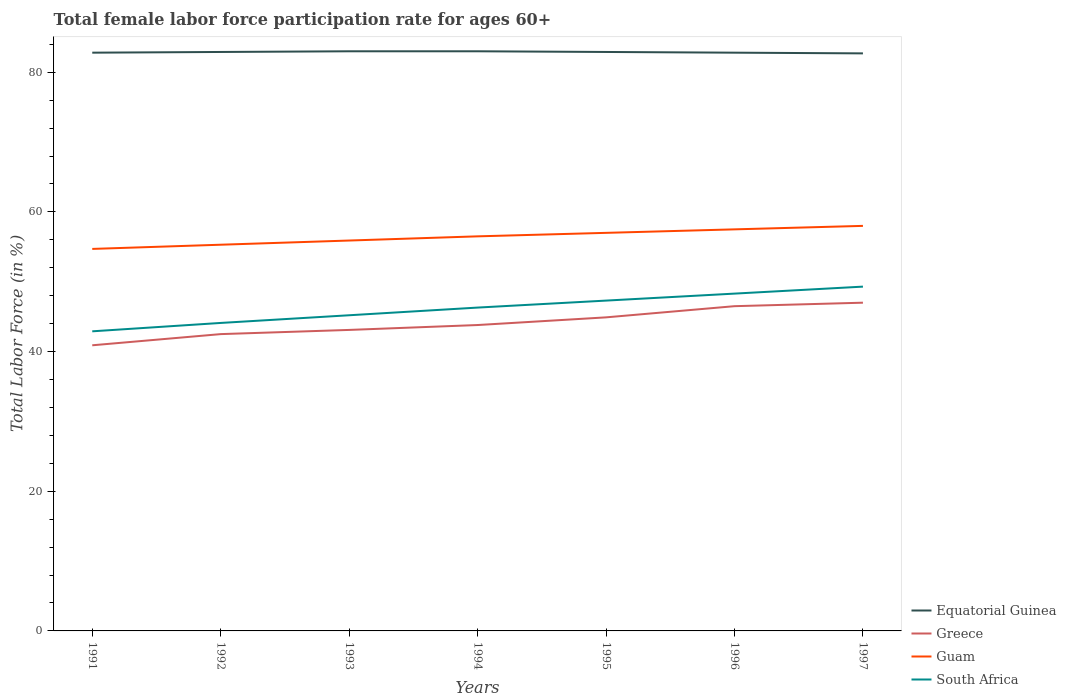How many different coloured lines are there?
Your answer should be very brief. 4. Does the line corresponding to Greece intersect with the line corresponding to South Africa?
Offer a very short reply. No. Is the number of lines equal to the number of legend labels?
Your answer should be very brief. Yes. Across all years, what is the maximum female labor force participation rate in Greece?
Your answer should be compact. 40.9. In which year was the female labor force participation rate in Greece maximum?
Offer a very short reply. 1991. What is the total female labor force participation rate in Greece in the graph?
Offer a terse response. -1.1. What is the difference between the highest and the second highest female labor force participation rate in Greece?
Your response must be concise. 6.1. What is the difference between the highest and the lowest female labor force participation rate in Guam?
Offer a very short reply. 4. How many lines are there?
Ensure brevity in your answer.  4. What is the difference between two consecutive major ticks on the Y-axis?
Provide a succinct answer. 20. Where does the legend appear in the graph?
Keep it short and to the point. Bottom right. What is the title of the graph?
Your answer should be compact. Total female labor force participation rate for ages 60+. What is the label or title of the Y-axis?
Your response must be concise. Total Labor Force (in %). What is the Total Labor Force (in %) in Equatorial Guinea in 1991?
Your response must be concise. 82.8. What is the Total Labor Force (in %) in Greece in 1991?
Your answer should be very brief. 40.9. What is the Total Labor Force (in %) in Guam in 1991?
Ensure brevity in your answer.  54.7. What is the Total Labor Force (in %) of South Africa in 1991?
Provide a short and direct response. 42.9. What is the Total Labor Force (in %) of Equatorial Guinea in 1992?
Keep it short and to the point. 82.9. What is the Total Labor Force (in %) of Greece in 1992?
Provide a succinct answer. 42.5. What is the Total Labor Force (in %) of Guam in 1992?
Offer a terse response. 55.3. What is the Total Labor Force (in %) of South Africa in 1992?
Offer a very short reply. 44.1. What is the Total Labor Force (in %) of Equatorial Guinea in 1993?
Your response must be concise. 83. What is the Total Labor Force (in %) of Greece in 1993?
Your answer should be compact. 43.1. What is the Total Labor Force (in %) of Guam in 1993?
Offer a very short reply. 55.9. What is the Total Labor Force (in %) of South Africa in 1993?
Make the answer very short. 45.2. What is the Total Labor Force (in %) in Greece in 1994?
Give a very brief answer. 43.8. What is the Total Labor Force (in %) of Guam in 1994?
Your response must be concise. 56.5. What is the Total Labor Force (in %) of South Africa in 1994?
Your answer should be compact. 46.3. What is the Total Labor Force (in %) of Equatorial Guinea in 1995?
Keep it short and to the point. 82.9. What is the Total Labor Force (in %) in Greece in 1995?
Keep it short and to the point. 44.9. What is the Total Labor Force (in %) in Guam in 1995?
Ensure brevity in your answer.  57. What is the Total Labor Force (in %) in South Africa in 1995?
Your answer should be very brief. 47.3. What is the Total Labor Force (in %) of Equatorial Guinea in 1996?
Offer a terse response. 82.8. What is the Total Labor Force (in %) of Greece in 1996?
Ensure brevity in your answer.  46.5. What is the Total Labor Force (in %) of Guam in 1996?
Offer a terse response. 57.5. What is the Total Labor Force (in %) in South Africa in 1996?
Ensure brevity in your answer.  48.3. What is the Total Labor Force (in %) in Equatorial Guinea in 1997?
Provide a succinct answer. 82.7. What is the Total Labor Force (in %) in Guam in 1997?
Ensure brevity in your answer.  58. What is the Total Labor Force (in %) in South Africa in 1997?
Offer a terse response. 49.3. Across all years, what is the maximum Total Labor Force (in %) in Equatorial Guinea?
Your answer should be very brief. 83. Across all years, what is the maximum Total Labor Force (in %) of Greece?
Give a very brief answer. 47. Across all years, what is the maximum Total Labor Force (in %) of South Africa?
Provide a short and direct response. 49.3. Across all years, what is the minimum Total Labor Force (in %) in Equatorial Guinea?
Give a very brief answer. 82.7. Across all years, what is the minimum Total Labor Force (in %) in Greece?
Your answer should be compact. 40.9. Across all years, what is the minimum Total Labor Force (in %) of Guam?
Your response must be concise. 54.7. Across all years, what is the minimum Total Labor Force (in %) of South Africa?
Provide a short and direct response. 42.9. What is the total Total Labor Force (in %) in Equatorial Guinea in the graph?
Provide a succinct answer. 580.1. What is the total Total Labor Force (in %) in Greece in the graph?
Provide a succinct answer. 308.7. What is the total Total Labor Force (in %) of Guam in the graph?
Your response must be concise. 394.9. What is the total Total Labor Force (in %) of South Africa in the graph?
Provide a short and direct response. 323.4. What is the difference between the Total Labor Force (in %) of Equatorial Guinea in 1991 and that in 1992?
Make the answer very short. -0.1. What is the difference between the Total Labor Force (in %) of South Africa in 1991 and that in 1992?
Offer a very short reply. -1.2. What is the difference between the Total Labor Force (in %) in Equatorial Guinea in 1991 and that in 1993?
Offer a very short reply. -0.2. What is the difference between the Total Labor Force (in %) of Equatorial Guinea in 1991 and that in 1994?
Provide a succinct answer. -0.2. What is the difference between the Total Labor Force (in %) of Guam in 1991 and that in 1994?
Your response must be concise. -1.8. What is the difference between the Total Labor Force (in %) of Equatorial Guinea in 1991 and that in 1995?
Offer a terse response. -0.1. What is the difference between the Total Labor Force (in %) of Equatorial Guinea in 1991 and that in 1996?
Your answer should be compact. 0. What is the difference between the Total Labor Force (in %) in Greece in 1991 and that in 1996?
Ensure brevity in your answer.  -5.6. What is the difference between the Total Labor Force (in %) in Guam in 1991 and that in 1996?
Make the answer very short. -2.8. What is the difference between the Total Labor Force (in %) of Guam in 1991 and that in 1997?
Ensure brevity in your answer.  -3.3. What is the difference between the Total Labor Force (in %) of South Africa in 1991 and that in 1997?
Offer a terse response. -6.4. What is the difference between the Total Labor Force (in %) in Greece in 1992 and that in 1993?
Your answer should be very brief. -0.6. What is the difference between the Total Labor Force (in %) of Guam in 1992 and that in 1993?
Your answer should be very brief. -0.6. What is the difference between the Total Labor Force (in %) in South Africa in 1992 and that in 1993?
Keep it short and to the point. -1.1. What is the difference between the Total Labor Force (in %) of Guam in 1992 and that in 1994?
Your answer should be compact. -1.2. What is the difference between the Total Labor Force (in %) of Guam in 1992 and that in 1995?
Offer a very short reply. -1.7. What is the difference between the Total Labor Force (in %) in Equatorial Guinea in 1992 and that in 1996?
Make the answer very short. 0.1. What is the difference between the Total Labor Force (in %) in South Africa in 1992 and that in 1996?
Give a very brief answer. -4.2. What is the difference between the Total Labor Force (in %) in Equatorial Guinea in 1992 and that in 1997?
Your answer should be compact. 0.2. What is the difference between the Total Labor Force (in %) of Greece in 1992 and that in 1997?
Provide a short and direct response. -4.5. What is the difference between the Total Labor Force (in %) in South Africa in 1992 and that in 1997?
Your response must be concise. -5.2. What is the difference between the Total Labor Force (in %) in Guam in 1993 and that in 1994?
Provide a short and direct response. -0.6. What is the difference between the Total Labor Force (in %) of South Africa in 1993 and that in 1994?
Offer a very short reply. -1.1. What is the difference between the Total Labor Force (in %) in Guam in 1993 and that in 1995?
Your answer should be very brief. -1.1. What is the difference between the Total Labor Force (in %) in South Africa in 1993 and that in 1995?
Provide a succinct answer. -2.1. What is the difference between the Total Labor Force (in %) of South Africa in 1993 and that in 1996?
Make the answer very short. -3.1. What is the difference between the Total Labor Force (in %) of Guam in 1993 and that in 1997?
Give a very brief answer. -2.1. What is the difference between the Total Labor Force (in %) in Greece in 1994 and that in 1995?
Make the answer very short. -1.1. What is the difference between the Total Labor Force (in %) in Guam in 1994 and that in 1995?
Your answer should be very brief. -0.5. What is the difference between the Total Labor Force (in %) of South Africa in 1994 and that in 1995?
Keep it short and to the point. -1. What is the difference between the Total Labor Force (in %) of Greece in 1994 and that in 1996?
Make the answer very short. -2.7. What is the difference between the Total Labor Force (in %) of South Africa in 1994 and that in 1996?
Make the answer very short. -2. What is the difference between the Total Labor Force (in %) in South Africa in 1994 and that in 1997?
Your answer should be compact. -3. What is the difference between the Total Labor Force (in %) in South Africa in 1995 and that in 1996?
Give a very brief answer. -1. What is the difference between the Total Labor Force (in %) in Equatorial Guinea in 1995 and that in 1997?
Your answer should be compact. 0.2. What is the difference between the Total Labor Force (in %) in Guam in 1995 and that in 1997?
Your answer should be compact. -1. What is the difference between the Total Labor Force (in %) in South Africa in 1995 and that in 1997?
Give a very brief answer. -2. What is the difference between the Total Labor Force (in %) in Equatorial Guinea in 1996 and that in 1997?
Offer a terse response. 0.1. What is the difference between the Total Labor Force (in %) in Greece in 1996 and that in 1997?
Provide a succinct answer. -0.5. What is the difference between the Total Labor Force (in %) in South Africa in 1996 and that in 1997?
Offer a terse response. -1. What is the difference between the Total Labor Force (in %) in Equatorial Guinea in 1991 and the Total Labor Force (in %) in Greece in 1992?
Offer a terse response. 40.3. What is the difference between the Total Labor Force (in %) of Equatorial Guinea in 1991 and the Total Labor Force (in %) of Guam in 1992?
Your answer should be compact. 27.5. What is the difference between the Total Labor Force (in %) in Equatorial Guinea in 1991 and the Total Labor Force (in %) in South Africa in 1992?
Make the answer very short. 38.7. What is the difference between the Total Labor Force (in %) in Greece in 1991 and the Total Labor Force (in %) in Guam in 1992?
Provide a succinct answer. -14.4. What is the difference between the Total Labor Force (in %) of Greece in 1991 and the Total Labor Force (in %) of South Africa in 1992?
Your response must be concise. -3.2. What is the difference between the Total Labor Force (in %) of Guam in 1991 and the Total Labor Force (in %) of South Africa in 1992?
Your answer should be very brief. 10.6. What is the difference between the Total Labor Force (in %) in Equatorial Guinea in 1991 and the Total Labor Force (in %) in Greece in 1993?
Give a very brief answer. 39.7. What is the difference between the Total Labor Force (in %) of Equatorial Guinea in 1991 and the Total Labor Force (in %) of Guam in 1993?
Your answer should be compact. 26.9. What is the difference between the Total Labor Force (in %) in Equatorial Guinea in 1991 and the Total Labor Force (in %) in South Africa in 1993?
Provide a short and direct response. 37.6. What is the difference between the Total Labor Force (in %) in Equatorial Guinea in 1991 and the Total Labor Force (in %) in Guam in 1994?
Make the answer very short. 26.3. What is the difference between the Total Labor Force (in %) in Equatorial Guinea in 1991 and the Total Labor Force (in %) in South Africa in 1994?
Provide a succinct answer. 36.5. What is the difference between the Total Labor Force (in %) of Greece in 1991 and the Total Labor Force (in %) of Guam in 1994?
Give a very brief answer. -15.6. What is the difference between the Total Labor Force (in %) in Greece in 1991 and the Total Labor Force (in %) in South Africa in 1994?
Give a very brief answer. -5.4. What is the difference between the Total Labor Force (in %) of Equatorial Guinea in 1991 and the Total Labor Force (in %) of Greece in 1995?
Keep it short and to the point. 37.9. What is the difference between the Total Labor Force (in %) in Equatorial Guinea in 1991 and the Total Labor Force (in %) in Guam in 1995?
Offer a terse response. 25.8. What is the difference between the Total Labor Force (in %) of Equatorial Guinea in 1991 and the Total Labor Force (in %) of South Africa in 1995?
Provide a short and direct response. 35.5. What is the difference between the Total Labor Force (in %) in Greece in 1991 and the Total Labor Force (in %) in Guam in 1995?
Your response must be concise. -16.1. What is the difference between the Total Labor Force (in %) of Guam in 1991 and the Total Labor Force (in %) of South Africa in 1995?
Give a very brief answer. 7.4. What is the difference between the Total Labor Force (in %) of Equatorial Guinea in 1991 and the Total Labor Force (in %) of Greece in 1996?
Provide a succinct answer. 36.3. What is the difference between the Total Labor Force (in %) in Equatorial Guinea in 1991 and the Total Labor Force (in %) in Guam in 1996?
Provide a succinct answer. 25.3. What is the difference between the Total Labor Force (in %) in Equatorial Guinea in 1991 and the Total Labor Force (in %) in South Africa in 1996?
Provide a succinct answer. 34.5. What is the difference between the Total Labor Force (in %) of Greece in 1991 and the Total Labor Force (in %) of Guam in 1996?
Offer a very short reply. -16.6. What is the difference between the Total Labor Force (in %) of Guam in 1991 and the Total Labor Force (in %) of South Africa in 1996?
Ensure brevity in your answer.  6.4. What is the difference between the Total Labor Force (in %) in Equatorial Guinea in 1991 and the Total Labor Force (in %) in Greece in 1997?
Keep it short and to the point. 35.8. What is the difference between the Total Labor Force (in %) in Equatorial Guinea in 1991 and the Total Labor Force (in %) in Guam in 1997?
Provide a short and direct response. 24.8. What is the difference between the Total Labor Force (in %) of Equatorial Guinea in 1991 and the Total Labor Force (in %) of South Africa in 1997?
Your response must be concise. 33.5. What is the difference between the Total Labor Force (in %) in Greece in 1991 and the Total Labor Force (in %) in Guam in 1997?
Offer a terse response. -17.1. What is the difference between the Total Labor Force (in %) of Guam in 1991 and the Total Labor Force (in %) of South Africa in 1997?
Provide a succinct answer. 5.4. What is the difference between the Total Labor Force (in %) of Equatorial Guinea in 1992 and the Total Labor Force (in %) of Greece in 1993?
Your response must be concise. 39.8. What is the difference between the Total Labor Force (in %) of Equatorial Guinea in 1992 and the Total Labor Force (in %) of South Africa in 1993?
Make the answer very short. 37.7. What is the difference between the Total Labor Force (in %) in Greece in 1992 and the Total Labor Force (in %) in Guam in 1993?
Keep it short and to the point. -13.4. What is the difference between the Total Labor Force (in %) in Greece in 1992 and the Total Labor Force (in %) in South Africa in 1993?
Keep it short and to the point. -2.7. What is the difference between the Total Labor Force (in %) in Guam in 1992 and the Total Labor Force (in %) in South Africa in 1993?
Provide a short and direct response. 10.1. What is the difference between the Total Labor Force (in %) of Equatorial Guinea in 1992 and the Total Labor Force (in %) of Greece in 1994?
Ensure brevity in your answer.  39.1. What is the difference between the Total Labor Force (in %) of Equatorial Guinea in 1992 and the Total Labor Force (in %) of Guam in 1994?
Your answer should be compact. 26.4. What is the difference between the Total Labor Force (in %) in Equatorial Guinea in 1992 and the Total Labor Force (in %) in South Africa in 1994?
Offer a very short reply. 36.6. What is the difference between the Total Labor Force (in %) in Greece in 1992 and the Total Labor Force (in %) in Guam in 1994?
Ensure brevity in your answer.  -14. What is the difference between the Total Labor Force (in %) of Greece in 1992 and the Total Labor Force (in %) of South Africa in 1994?
Your answer should be very brief. -3.8. What is the difference between the Total Labor Force (in %) of Guam in 1992 and the Total Labor Force (in %) of South Africa in 1994?
Offer a terse response. 9. What is the difference between the Total Labor Force (in %) in Equatorial Guinea in 1992 and the Total Labor Force (in %) in Guam in 1995?
Ensure brevity in your answer.  25.9. What is the difference between the Total Labor Force (in %) of Equatorial Guinea in 1992 and the Total Labor Force (in %) of South Africa in 1995?
Give a very brief answer. 35.6. What is the difference between the Total Labor Force (in %) of Equatorial Guinea in 1992 and the Total Labor Force (in %) of Greece in 1996?
Provide a short and direct response. 36.4. What is the difference between the Total Labor Force (in %) in Equatorial Guinea in 1992 and the Total Labor Force (in %) in Guam in 1996?
Make the answer very short. 25.4. What is the difference between the Total Labor Force (in %) of Equatorial Guinea in 1992 and the Total Labor Force (in %) of South Africa in 1996?
Your response must be concise. 34.6. What is the difference between the Total Labor Force (in %) in Greece in 1992 and the Total Labor Force (in %) in South Africa in 1996?
Give a very brief answer. -5.8. What is the difference between the Total Labor Force (in %) of Equatorial Guinea in 1992 and the Total Labor Force (in %) of Greece in 1997?
Provide a succinct answer. 35.9. What is the difference between the Total Labor Force (in %) of Equatorial Guinea in 1992 and the Total Labor Force (in %) of Guam in 1997?
Provide a short and direct response. 24.9. What is the difference between the Total Labor Force (in %) in Equatorial Guinea in 1992 and the Total Labor Force (in %) in South Africa in 1997?
Ensure brevity in your answer.  33.6. What is the difference between the Total Labor Force (in %) in Greece in 1992 and the Total Labor Force (in %) in Guam in 1997?
Offer a very short reply. -15.5. What is the difference between the Total Labor Force (in %) in Equatorial Guinea in 1993 and the Total Labor Force (in %) in Greece in 1994?
Your answer should be compact. 39.2. What is the difference between the Total Labor Force (in %) of Equatorial Guinea in 1993 and the Total Labor Force (in %) of South Africa in 1994?
Give a very brief answer. 36.7. What is the difference between the Total Labor Force (in %) of Greece in 1993 and the Total Labor Force (in %) of South Africa in 1994?
Your response must be concise. -3.2. What is the difference between the Total Labor Force (in %) in Guam in 1993 and the Total Labor Force (in %) in South Africa in 1994?
Your answer should be compact. 9.6. What is the difference between the Total Labor Force (in %) of Equatorial Guinea in 1993 and the Total Labor Force (in %) of Greece in 1995?
Provide a short and direct response. 38.1. What is the difference between the Total Labor Force (in %) in Equatorial Guinea in 1993 and the Total Labor Force (in %) in Guam in 1995?
Offer a very short reply. 26. What is the difference between the Total Labor Force (in %) of Equatorial Guinea in 1993 and the Total Labor Force (in %) of South Africa in 1995?
Provide a succinct answer. 35.7. What is the difference between the Total Labor Force (in %) in Equatorial Guinea in 1993 and the Total Labor Force (in %) in Greece in 1996?
Your response must be concise. 36.5. What is the difference between the Total Labor Force (in %) in Equatorial Guinea in 1993 and the Total Labor Force (in %) in Guam in 1996?
Offer a very short reply. 25.5. What is the difference between the Total Labor Force (in %) in Equatorial Guinea in 1993 and the Total Labor Force (in %) in South Africa in 1996?
Keep it short and to the point. 34.7. What is the difference between the Total Labor Force (in %) in Greece in 1993 and the Total Labor Force (in %) in Guam in 1996?
Your answer should be compact. -14.4. What is the difference between the Total Labor Force (in %) of Greece in 1993 and the Total Labor Force (in %) of South Africa in 1996?
Your response must be concise. -5.2. What is the difference between the Total Labor Force (in %) of Equatorial Guinea in 1993 and the Total Labor Force (in %) of South Africa in 1997?
Offer a very short reply. 33.7. What is the difference between the Total Labor Force (in %) in Greece in 1993 and the Total Labor Force (in %) in Guam in 1997?
Keep it short and to the point. -14.9. What is the difference between the Total Labor Force (in %) in Equatorial Guinea in 1994 and the Total Labor Force (in %) in Greece in 1995?
Give a very brief answer. 38.1. What is the difference between the Total Labor Force (in %) of Equatorial Guinea in 1994 and the Total Labor Force (in %) of South Africa in 1995?
Offer a terse response. 35.7. What is the difference between the Total Labor Force (in %) of Greece in 1994 and the Total Labor Force (in %) of Guam in 1995?
Your answer should be very brief. -13.2. What is the difference between the Total Labor Force (in %) of Guam in 1994 and the Total Labor Force (in %) of South Africa in 1995?
Offer a very short reply. 9.2. What is the difference between the Total Labor Force (in %) in Equatorial Guinea in 1994 and the Total Labor Force (in %) in Greece in 1996?
Ensure brevity in your answer.  36.5. What is the difference between the Total Labor Force (in %) in Equatorial Guinea in 1994 and the Total Labor Force (in %) in South Africa in 1996?
Provide a short and direct response. 34.7. What is the difference between the Total Labor Force (in %) of Greece in 1994 and the Total Labor Force (in %) of Guam in 1996?
Provide a short and direct response. -13.7. What is the difference between the Total Labor Force (in %) of Greece in 1994 and the Total Labor Force (in %) of South Africa in 1996?
Provide a succinct answer. -4.5. What is the difference between the Total Labor Force (in %) in Equatorial Guinea in 1994 and the Total Labor Force (in %) in South Africa in 1997?
Keep it short and to the point. 33.7. What is the difference between the Total Labor Force (in %) of Greece in 1994 and the Total Labor Force (in %) of Guam in 1997?
Your response must be concise. -14.2. What is the difference between the Total Labor Force (in %) in Guam in 1994 and the Total Labor Force (in %) in South Africa in 1997?
Your response must be concise. 7.2. What is the difference between the Total Labor Force (in %) in Equatorial Guinea in 1995 and the Total Labor Force (in %) in Greece in 1996?
Ensure brevity in your answer.  36.4. What is the difference between the Total Labor Force (in %) in Equatorial Guinea in 1995 and the Total Labor Force (in %) in Guam in 1996?
Offer a very short reply. 25.4. What is the difference between the Total Labor Force (in %) in Equatorial Guinea in 1995 and the Total Labor Force (in %) in South Africa in 1996?
Give a very brief answer. 34.6. What is the difference between the Total Labor Force (in %) of Greece in 1995 and the Total Labor Force (in %) of Guam in 1996?
Offer a terse response. -12.6. What is the difference between the Total Labor Force (in %) in Greece in 1995 and the Total Labor Force (in %) in South Africa in 1996?
Your answer should be very brief. -3.4. What is the difference between the Total Labor Force (in %) of Equatorial Guinea in 1995 and the Total Labor Force (in %) of Greece in 1997?
Provide a short and direct response. 35.9. What is the difference between the Total Labor Force (in %) in Equatorial Guinea in 1995 and the Total Labor Force (in %) in Guam in 1997?
Give a very brief answer. 24.9. What is the difference between the Total Labor Force (in %) in Equatorial Guinea in 1995 and the Total Labor Force (in %) in South Africa in 1997?
Offer a very short reply. 33.6. What is the difference between the Total Labor Force (in %) of Greece in 1995 and the Total Labor Force (in %) of Guam in 1997?
Ensure brevity in your answer.  -13.1. What is the difference between the Total Labor Force (in %) of Greece in 1995 and the Total Labor Force (in %) of South Africa in 1997?
Offer a very short reply. -4.4. What is the difference between the Total Labor Force (in %) of Equatorial Guinea in 1996 and the Total Labor Force (in %) of Greece in 1997?
Your answer should be compact. 35.8. What is the difference between the Total Labor Force (in %) in Equatorial Guinea in 1996 and the Total Labor Force (in %) in Guam in 1997?
Your answer should be compact. 24.8. What is the difference between the Total Labor Force (in %) in Equatorial Guinea in 1996 and the Total Labor Force (in %) in South Africa in 1997?
Ensure brevity in your answer.  33.5. What is the difference between the Total Labor Force (in %) of Guam in 1996 and the Total Labor Force (in %) of South Africa in 1997?
Give a very brief answer. 8.2. What is the average Total Labor Force (in %) of Equatorial Guinea per year?
Your answer should be very brief. 82.87. What is the average Total Labor Force (in %) of Greece per year?
Your response must be concise. 44.1. What is the average Total Labor Force (in %) of Guam per year?
Offer a terse response. 56.41. What is the average Total Labor Force (in %) of South Africa per year?
Offer a terse response. 46.2. In the year 1991, what is the difference between the Total Labor Force (in %) in Equatorial Guinea and Total Labor Force (in %) in Greece?
Your answer should be very brief. 41.9. In the year 1991, what is the difference between the Total Labor Force (in %) of Equatorial Guinea and Total Labor Force (in %) of Guam?
Your answer should be compact. 28.1. In the year 1991, what is the difference between the Total Labor Force (in %) of Equatorial Guinea and Total Labor Force (in %) of South Africa?
Offer a very short reply. 39.9. In the year 1992, what is the difference between the Total Labor Force (in %) of Equatorial Guinea and Total Labor Force (in %) of Greece?
Provide a succinct answer. 40.4. In the year 1992, what is the difference between the Total Labor Force (in %) in Equatorial Guinea and Total Labor Force (in %) in Guam?
Your answer should be very brief. 27.6. In the year 1992, what is the difference between the Total Labor Force (in %) of Equatorial Guinea and Total Labor Force (in %) of South Africa?
Offer a terse response. 38.8. In the year 1992, what is the difference between the Total Labor Force (in %) of Greece and Total Labor Force (in %) of Guam?
Keep it short and to the point. -12.8. In the year 1992, what is the difference between the Total Labor Force (in %) of Greece and Total Labor Force (in %) of South Africa?
Give a very brief answer. -1.6. In the year 1992, what is the difference between the Total Labor Force (in %) of Guam and Total Labor Force (in %) of South Africa?
Give a very brief answer. 11.2. In the year 1993, what is the difference between the Total Labor Force (in %) in Equatorial Guinea and Total Labor Force (in %) in Greece?
Provide a succinct answer. 39.9. In the year 1993, what is the difference between the Total Labor Force (in %) in Equatorial Guinea and Total Labor Force (in %) in Guam?
Offer a very short reply. 27.1. In the year 1993, what is the difference between the Total Labor Force (in %) of Equatorial Guinea and Total Labor Force (in %) of South Africa?
Give a very brief answer. 37.8. In the year 1993, what is the difference between the Total Labor Force (in %) of Greece and Total Labor Force (in %) of South Africa?
Your answer should be very brief. -2.1. In the year 1994, what is the difference between the Total Labor Force (in %) in Equatorial Guinea and Total Labor Force (in %) in Greece?
Ensure brevity in your answer.  39.2. In the year 1994, what is the difference between the Total Labor Force (in %) in Equatorial Guinea and Total Labor Force (in %) in Guam?
Your answer should be very brief. 26.5. In the year 1994, what is the difference between the Total Labor Force (in %) in Equatorial Guinea and Total Labor Force (in %) in South Africa?
Offer a very short reply. 36.7. In the year 1994, what is the difference between the Total Labor Force (in %) of Greece and Total Labor Force (in %) of Guam?
Your response must be concise. -12.7. In the year 1994, what is the difference between the Total Labor Force (in %) of Greece and Total Labor Force (in %) of South Africa?
Your response must be concise. -2.5. In the year 1994, what is the difference between the Total Labor Force (in %) in Guam and Total Labor Force (in %) in South Africa?
Give a very brief answer. 10.2. In the year 1995, what is the difference between the Total Labor Force (in %) in Equatorial Guinea and Total Labor Force (in %) in Greece?
Keep it short and to the point. 38. In the year 1995, what is the difference between the Total Labor Force (in %) in Equatorial Guinea and Total Labor Force (in %) in Guam?
Your answer should be compact. 25.9. In the year 1995, what is the difference between the Total Labor Force (in %) of Equatorial Guinea and Total Labor Force (in %) of South Africa?
Keep it short and to the point. 35.6. In the year 1995, what is the difference between the Total Labor Force (in %) in Guam and Total Labor Force (in %) in South Africa?
Make the answer very short. 9.7. In the year 1996, what is the difference between the Total Labor Force (in %) of Equatorial Guinea and Total Labor Force (in %) of Greece?
Provide a succinct answer. 36.3. In the year 1996, what is the difference between the Total Labor Force (in %) in Equatorial Guinea and Total Labor Force (in %) in Guam?
Offer a very short reply. 25.3. In the year 1996, what is the difference between the Total Labor Force (in %) of Equatorial Guinea and Total Labor Force (in %) of South Africa?
Offer a very short reply. 34.5. In the year 1996, what is the difference between the Total Labor Force (in %) of Guam and Total Labor Force (in %) of South Africa?
Make the answer very short. 9.2. In the year 1997, what is the difference between the Total Labor Force (in %) in Equatorial Guinea and Total Labor Force (in %) in Greece?
Give a very brief answer. 35.7. In the year 1997, what is the difference between the Total Labor Force (in %) in Equatorial Guinea and Total Labor Force (in %) in Guam?
Offer a very short reply. 24.7. In the year 1997, what is the difference between the Total Labor Force (in %) in Equatorial Guinea and Total Labor Force (in %) in South Africa?
Give a very brief answer. 33.4. In the year 1997, what is the difference between the Total Labor Force (in %) of Greece and Total Labor Force (in %) of South Africa?
Give a very brief answer. -2.3. What is the ratio of the Total Labor Force (in %) in Equatorial Guinea in 1991 to that in 1992?
Your answer should be very brief. 1. What is the ratio of the Total Labor Force (in %) in Greece in 1991 to that in 1992?
Give a very brief answer. 0.96. What is the ratio of the Total Labor Force (in %) in Guam in 1991 to that in 1992?
Keep it short and to the point. 0.99. What is the ratio of the Total Labor Force (in %) of South Africa in 1991 to that in 1992?
Your answer should be compact. 0.97. What is the ratio of the Total Labor Force (in %) in Equatorial Guinea in 1991 to that in 1993?
Give a very brief answer. 1. What is the ratio of the Total Labor Force (in %) of Greece in 1991 to that in 1993?
Your answer should be compact. 0.95. What is the ratio of the Total Labor Force (in %) of Guam in 1991 to that in 1993?
Give a very brief answer. 0.98. What is the ratio of the Total Labor Force (in %) of South Africa in 1991 to that in 1993?
Make the answer very short. 0.95. What is the ratio of the Total Labor Force (in %) of Equatorial Guinea in 1991 to that in 1994?
Provide a short and direct response. 1. What is the ratio of the Total Labor Force (in %) in Greece in 1991 to that in 1994?
Your answer should be compact. 0.93. What is the ratio of the Total Labor Force (in %) in Guam in 1991 to that in 1994?
Your answer should be compact. 0.97. What is the ratio of the Total Labor Force (in %) in South Africa in 1991 to that in 1994?
Provide a succinct answer. 0.93. What is the ratio of the Total Labor Force (in %) of Greece in 1991 to that in 1995?
Ensure brevity in your answer.  0.91. What is the ratio of the Total Labor Force (in %) in Guam in 1991 to that in 1995?
Keep it short and to the point. 0.96. What is the ratio of the Total Labor Force (in %) of South Africa in 1991 to that in 1995?
Give a very brief answer. 0.91. What is the ratio of the Total Labor Force (in %) in Greece in 1991 to that in 1996?
Offer a terse response. 0.88. What is the ratio of the Total Labor Force (in %) of Guam in 1991 to that in 1996?
Offer a very short reply. 0.95. What is the ratio of the Total Labor Force (in %) of South Africa in 1991 to that in 1996?
Provide a succinct answer. 0.89. What is the ratio of the Total Labor Force (in %) of Greece in 1991 to that in 1997?
Your response must be concise. 0.87. What is the ratio of the Total Labor Force (in %) in Guam in 1991 to that in 1997?
Offer a terse response. 0.94. What is the ratio of the Total Labor Force (in %) in South Africa in 1991 to that in 1997?
Keep it short and to the point. 0.87. What is the ratio of the Total Labor Force (in %) of Equatorial Guinea in 1992 to that in 1993?
Keep it short and to the point. 1. What is the ratio of the Total Labor Force (in %) in Greece in 1992 to that in 1993?
Make the answer very short. 0.99. What is the ratio of the Total Labor Force (in %) of Guam in 1992 to that in 1993?
Keep it short and to the point. 0.99. What is the ratio of the Total Labor Force (in %) of South Africa in 1992 to that in 1993?
Offer a very short reply. 0.98. What is the ratio of the Total Labor Force (in %) in Equatorial Guinea in 1992 to that in 1994?
Provide a succinct answer. 1. What is the ratio of the Total Labor Force (in %) of Greece in 1992 to that in 1994?
Your response must be concise. 0.97. What is the ratio of the Total Labor Force (in %) in Guam in 1992 to that in 1994?
Offer a terse response. 0.98. What is the ratio of the Total Labor Force (in %) in South Africa in 1992 to that in 1994?
Give a very brief answer. 0.95. What is the ratio of the Total Labor Force (in %) of Equatorial Guinea in 1992 to that in 1995?
Ensure brevity in your answer.  1. What is the ratio of the Total Labor Force (in %) in Greece in 1992 to that in 1995?
Offer a terse response. 0.95. What is the ratio of the Total Labor Force (in %) of Guam in 1992 to that in 1995?
Offer a very short reply. 0.97. What is the ratio of the Total Labor Force (in %) of South Africa in 1992 to that in 1995?
Make the answer very short. 0.93. What is the ratio of the Total Labor Force (in %) in Greece in 1992 to that in 1996?
Keep it short and to the point. 0.91. What is the ratio of the Total Labor Force (in %) of Guam in 1992 to that in 1996?
Provide a succinct answer. 0.96. What is the ratio of the Total Labor Force (in %) in South Africa in 1992 to that in 1996?
Offer a terse response. 0.91. What is the ratio of the Total Labor Force (in %) in Equatorial Guinea in 1992 to that in 1997?
Your response must be concise. 1. What is the ratio of the Total Labor Force (in %) in Greece in 1992 to that in 1997?
Give a very brief answer. 0.9. What is the ratio of the Total Labor Force (in %) of Guam in 1992 to that in 1997?
Make the answer very short. 0.95. What is the ratio of the Total Labor Force (in %) of South Africa in 1992 to that in 1997?
Keep it short and to the point. 0.89. What is the ratio of the Total Labor Force (in %) of Greece in 1993 to that in 1994?
Provide a short and direct response. 0.98. What is the ratio of the Total Labor Force (in %) in Guam in 1993 to that in 1994?
Make the answer very short. 0.99. What is the ratio of the Total Labor Force (in %) of South Africa in 1993 to that in 1994?
Make the answer very short. 0.98. What is the ratio of the Total Labor Force (in %) of Greece in 1993 to that in 1995?
Provide a short and direct response. 0.96. What is the ratio of the Total Labor Force (in %) in Guam in 1993 to that in 1995?
Provide a short and direct response. 0.98. What is the ratio of the Total Labor Force (in %) in South Africa in 1993 to that in 1995?
Make the answer very short. 0.96. What is the ratio of the Total Labor Force (in %) in Greece in 1993 to that in 1996?
Ensure brevity in your answer.  0.93. What is the ratio of the Total Labor Force (in %) in Guam in 1993 to that in 1996?
Your answer should be compact. 0.97. What is the ratio of the Total Labor Force (in %) of South Africa in 1993 to that in 1996?
Your response must be concise. 0.94. What is the ratio of the Total Labor Force (in %) in Greece in 1993 to that in 1997?
Your answer should be very brief. 0.92. What is the ratio of the Total Labor Force (in %) in Guam in 1993 to that in 1997?
Give a very brief answer. 0.96. What is the ratio of the Total Labor Force (in %) of South Africa in 1993 to that in 1997?
Ensure brevity in your answer.  0.92. What is the ratio of the Total Labor Force (in %) of Equatorial Guinea in 1994 to that in 1995?
Provide a succinct answer. 1. What is the ratio of the Total Labor Force (in %) in Greece in 1994 to that in 1995?
Your answer should be very brief. 0.98. What is the ratio of the Total Labor Force (in %) of Guam in 1994 to that in 1995?
Keep it short and to the point. 0.99. What is the ratio of the Total Labor Force (in %) in South Africa in 1994 to that in 1995?
Your answer should be very brief. 0.98. What is the ratio of the Total Labor Force (in %) of Greece in 1994 to that in 1996?
Provide a short and direct response. 0.94. What is the ratio of the Total Labor Force (in %) in Guam in 1994 to that in 1996?
Your answer should be compact. 0.98. What is the ratio of the Total Labor Force (in %) of South Africa in 1994 to that in 1996?
Offer a terse response. 0.96. What is the ratio of the Total Labor Force (in %) in Greece in 1994 to that in 1997?
Your answer should be very brief. 0.93. What is the ratio of the Total Labor Force (in %) in Guam in 1994 to that in 1997?
Ensure brevity in your answer.  0.97. What is the ratio of the Total Labor Force (in %) of South Africa in 1994 to that in 1997?
Ensure brevity in your answer.  0.94. What is the ratio of the Total Labor Force (in %) in Equatorial Guinea in 1995 to that in 1996?
Your answer should be very brief. 1. What is the ratio of the Total Labor Force (in %) of Greece in 1995 to that in 1996?
Your answer should be compact. 0.97. What is the ratio of the Total Labor Force (in %) in South Africa in 1995 to that in 1996?
Your response must be concise. 0.98. What is the ratio of the Total Labor Force (in %) in Greece in 1995 to that in 1997?
Your response must be concise. 0.96. What is the ratio of the Total Labor Force (in %) in Guam in 1995 to that in 1997?
Provide a short and direct response. 0.98. What is the ratio of the Total Labor Force (in %) in South Africa in 1995 to that in 1997?
Offer a very short reply. 0.96. What is the ratio of the Total Labor Force (in %) in South Africa in 1996 to that in 1997?
Offer a terse response. 0.98. What is the difference between the highest and the second highest Total Labor Force (in %) in Greece?
Your response must be concise. 0.5. What is the difference between the highest and the lowest Total Labor Force (in %) in Greece?
Provide a short and direct response. 6.1. What is the difference between the highest and the lowest Total Labor Force (in %) of Guam?
Make the answer very short. 3.3. 